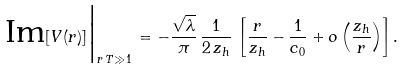<formula> <loc_0><loc_0><loc_500><loc_500>\text {Im} [ V ( r ) ] \Big | _ { r \, T \gg 1 } \, = - \frac { \sqrt { \lambda } } { \pi } \, \frac { 1 } { 2 \, z _ { h } } \, \left [ \frac { r } { z _ { h } } - \frac { 1 } { c _ { 0 } } + o \left ( \frac { z _ { h } } { r } \right ) \right ] .</formula> 